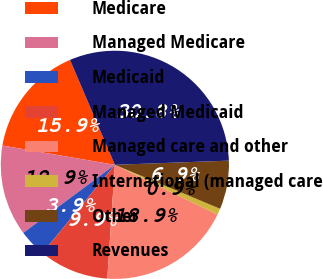<chart> <loc_0><loc_0><loc_500><loc_500><pie_chart><fcel>Medicare<fcel>Managed Medicare<fcel>Medicaid<fcel>Managed Medicaid<fcel>Managed care and other<fcel>International (managed care<fcel>Other<fcel>Revenues<nl><fcel>15.87%<fcel>12.87%<fcel>3.89%<fcel>9.88%<fcel>18.86%<fcel>0.89%<fcel>6.88%<fcel>30.84%<nl></chart> 